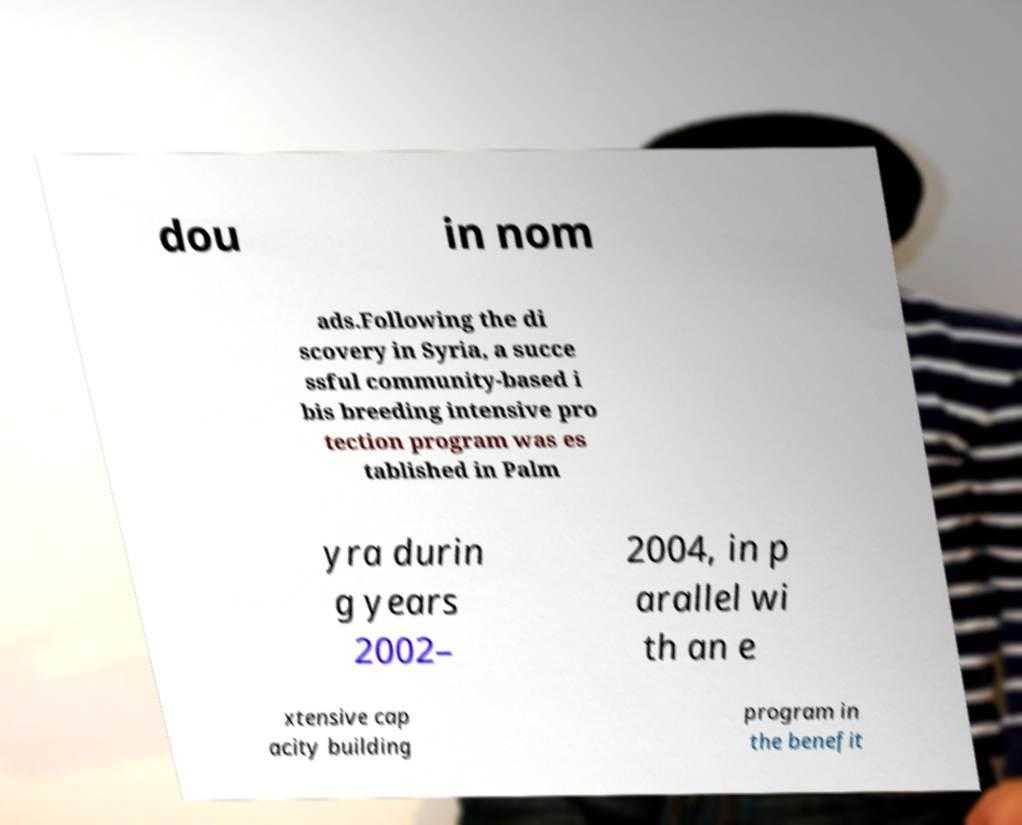Please read and relay the text visible in this image. What does it say? dou in nom ads.Following the di scovery in Syria, a succe ssful community-based i bis breeding intensive pro tection program was es tablished in Palm yra durin g years 2002– 2004, in p arallel wi th an e xtensive cap acity building program in the benefit 